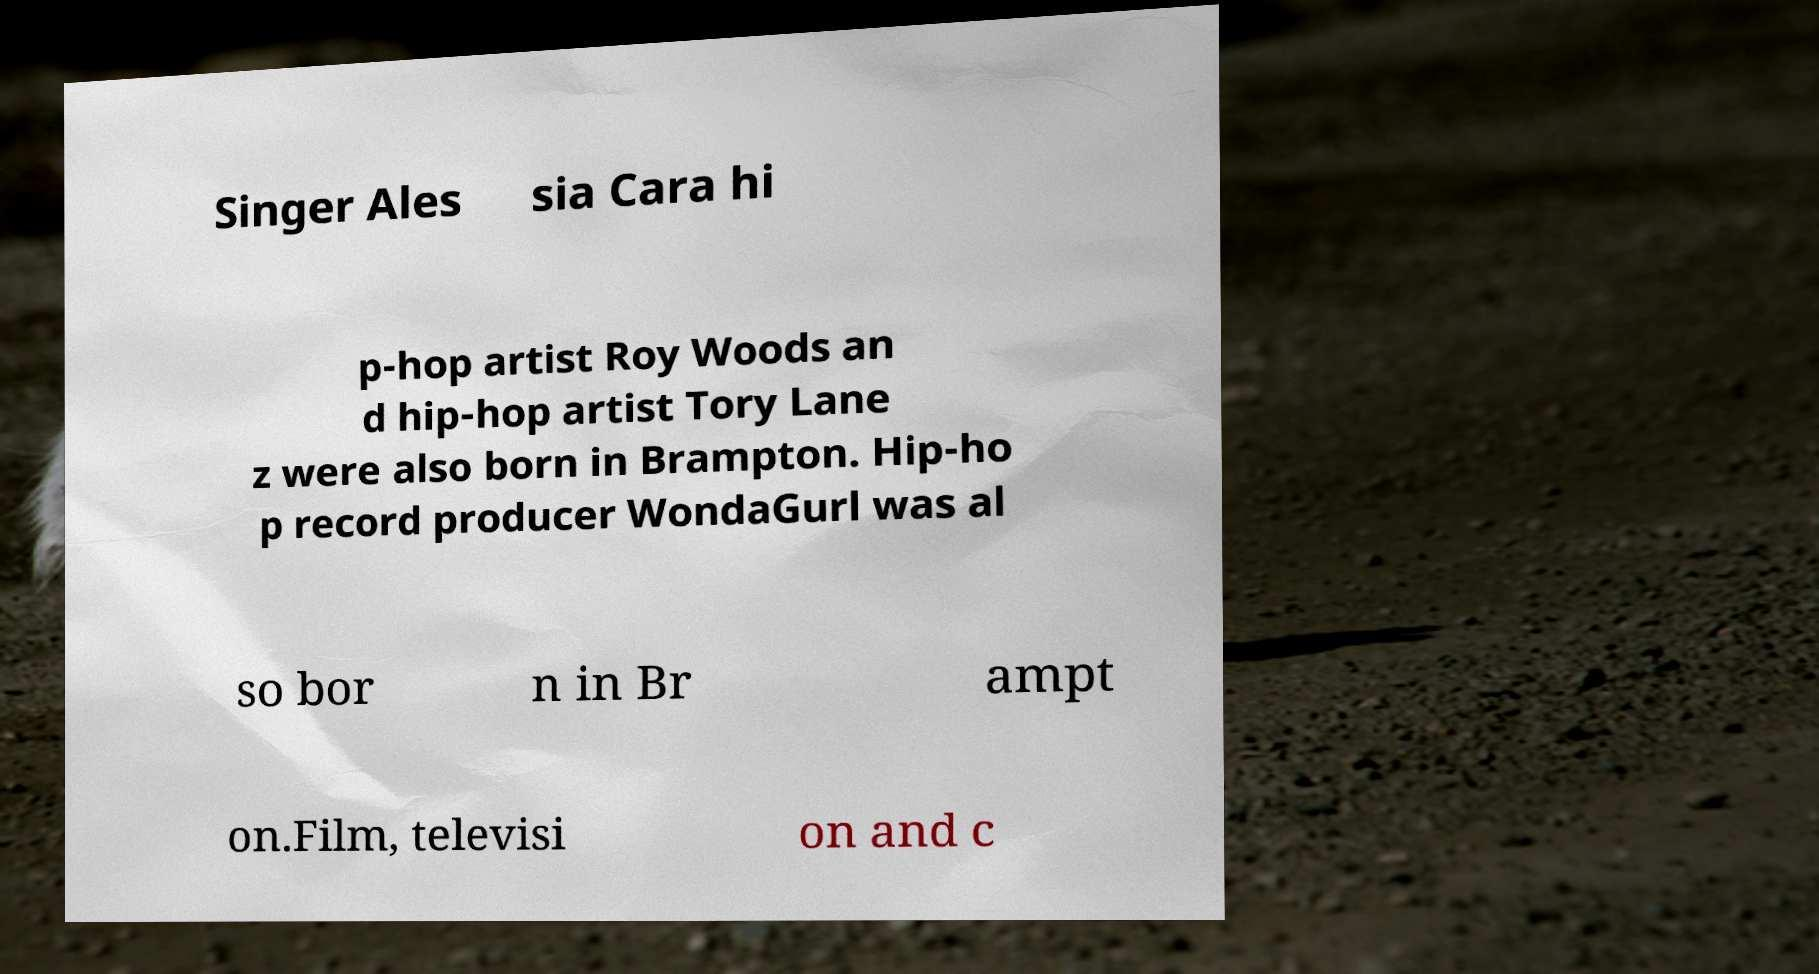What messages or text are displayed in this image? I need them in a readable, typed format. Singer Ales sia Cara hi p-hop artist Roy Woods an d hip-hop artist Tory Lane z were also born in Brampton. Hip-ho p record producer WondaGurl was al so bor n in Br ampt on.Film, televisi on and c 